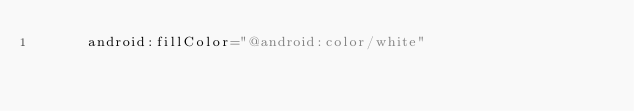Convert code to text. <code><loc_0><loc_0><loc_500><loc_500><_XML_>      android:fillColor="@android:color/white"</code> 